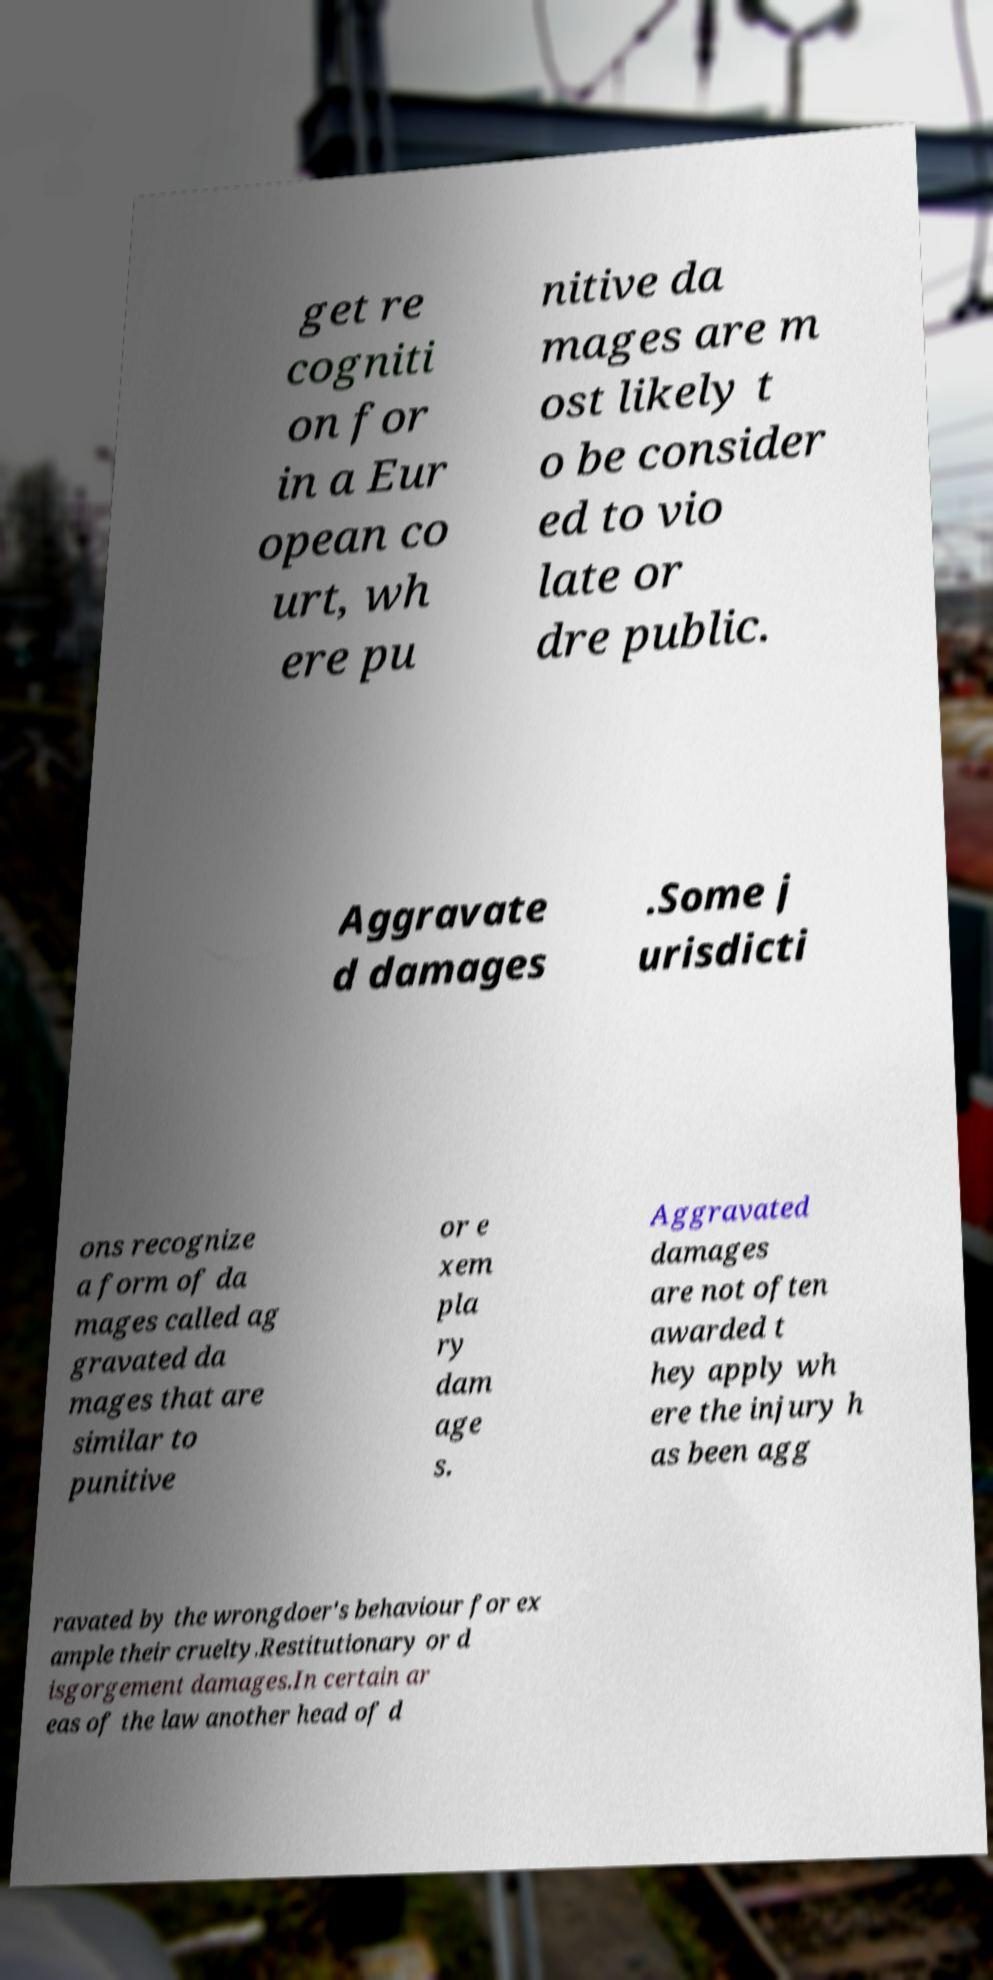There's text embedded in this image that I need extracted. Can you transcribe it verbatim? get re cogniti on for in a Eur opean co urt, wh ere pu nitive da mages are m ost likely t o be consider ed to vio late or dre public. Aggravate d damages .Some j urisdicti ons recognize a form of da mages called ag gravated da mages that are similar to punitive or e xem pla ry dam age s. Aggravated damages are not often awarded t hey apply wh ere the injury h as been agg ravated by the wrongdoer's behaviour for ex ample their cruelty.Restitutionary or d isgorgement damages.In certain ar eas of the law another head of d 